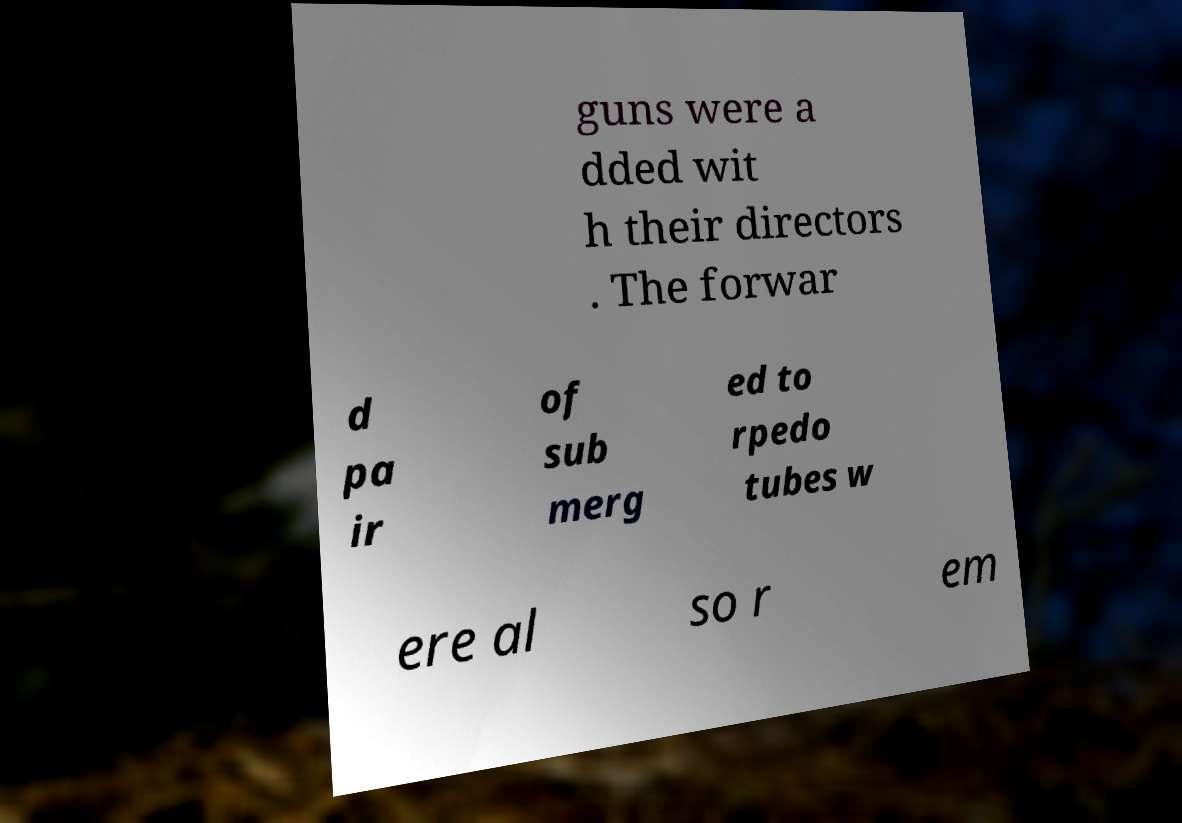Please identify and transcribe the text found in this image. guns were a dded wit h their directors . The forwar d pa ir of sub merg ed to rpedo tubes w ere al so r em 